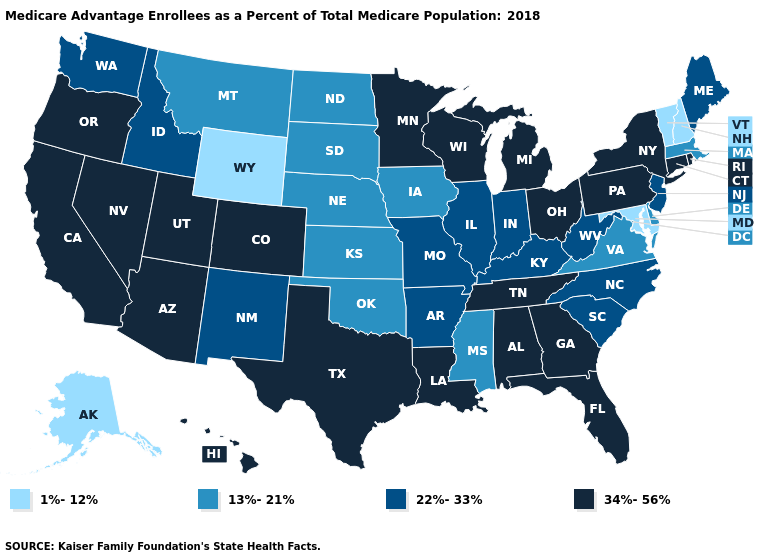What is the lowest value in the USA?
Short answer required. 1%-12%. Does the first symbol in the legend represent the smallest category?
Give a very brief answer. Yes. Which states have the highest value in the USA?
Keep it brief. Alabama, Arizona, California, Colorado, Connecticut, Florida, Georgia, Hawaii, Louisiana, Michigan, Minnesota, Nevada, New York, Ohio, Oregon, Pennsylvania, Rhode Island, Tennessee, Texas, Utah, Wisconsin. Which states have the highest value in the USA?
Be succinct. Alabama, Arizona, California, Colorado, Connecticut, Florida, Georgia, Hawaii, Louisiana, Michigan, Minnesota, Nevada, New York, Ohio, Oregon, Pennsylvania, Rhode Island, Tennessee, Texas, Utah, Wisconsin. Does the first symbol in the legend represent the smallest category?
Quick response, please. Yes. Which states have the highest value in the USA?
Keep it brief. Alabama, Arizona, California, Colorado, Connecticut, Florida, Georgia, Hawaii, Louisiana, Michigan, Minnesota, Nevada, New York, Ohio, Oregon, Pennsylvania, Rhode Island, Tennessee, Texas, Utah, Wisconsin. Does Tennessee have a higher value than Missouri?
Write a very short answer. Yes. What is the value of Nebraska?
Answer briefly. 13%-21%. Is the legend a continuous bar?
Short answer required. No. Which states have the lowest value in the Northeast?
Short answer required. New Hampshire, Vermont. Which states have the lowest value in the USA?
Write a very short answer. Alaska, Maryland, New Hampshire, Vermont, Wyoming. Does Wyoming have the lowest value in the USA?
Short answer required. Yes. Name the states that have a value in the range 34%-56%?
Concise answer only. Alabama, Arizona, California, Colorado, Connecticut, Florida, Georgia, Hawaii, Louisiana, Michigan, Minnesota, Nevada, New York, Ohio, Oregon, Pennsylvania, Rhode Island, Tennessee, Texas, Utah, Wisconsin. Name the states that have a value in the range 22%-33%?
Write a very short answer. Arkansas, Idaho, Illinois, Indiana, Kentucky, Maine, Missouri, New Jersey, New Mexico, North Carolina, South Carolina, Washington, West Virginia. Among the states that border Virginia , does Maryland have the highest value?
Write a very short answer. No. 